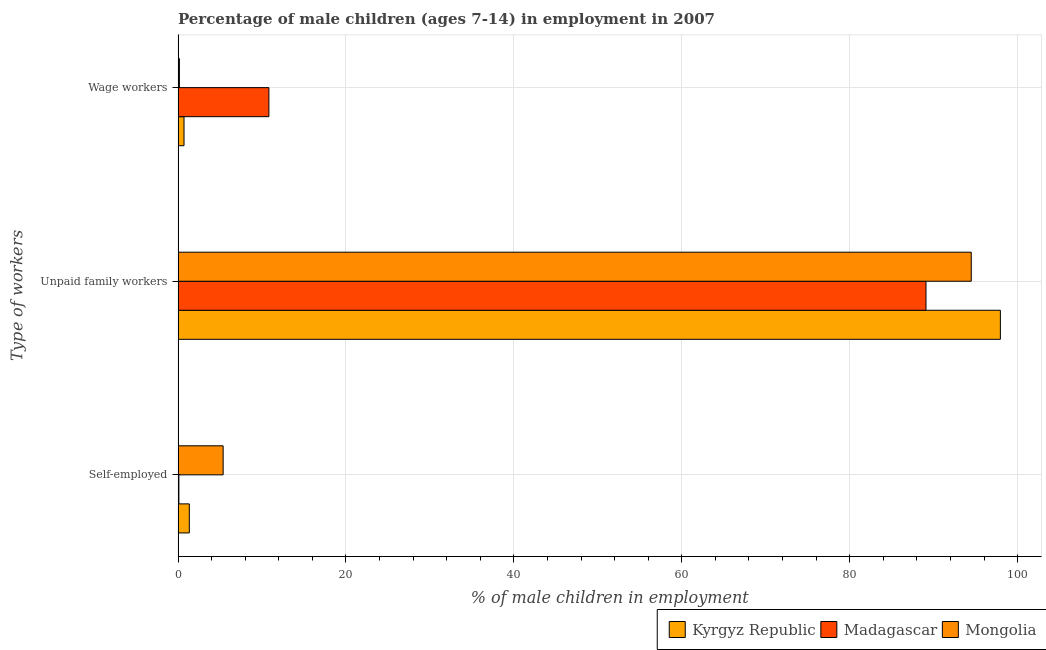How many different coloured bars are there?
Provide a short and direct response. 3. Are the number of bars on each tick of the Y-axis equal?
Offer a very short reply. Yes. What is the label of the 2nd group of bars from the top?
Your answer should be very brief. Unpaid family workers. What is the percentage of self employed children in Kyrgyz Republic?
Your answer should be very brief. 1.34. Across all countries, what is the maximum percentage of children employed as unpaid family workers?
Your answer should be very brief. 97.95. Across all countries, what is the minimum percentage of children employed as unpaid family workers?
Make the answer very short. 89.09. In which country was the percentage of children employed as wage workers maximum?
Offer a very short reply. Madagascar. In which country was the percentage of children employed as wage workers minimum?
Make the answer very short. Mongolia. What is the total percentage of children employed as wage workers in the graph?
Your answer should be compact. 11.69. What is the difference between the percentage of children employed as wage workers in Mongolia and that in Madagascar?
Make the answer very short. -10.66. What is the difference between the percentage of self employed children in Mongolia and the percentage of children employed as unpaid family workers in Madagascar?
Your answer should be compact. -83.72. What is the average percentage of self employed children per country?
Offer a terse response. 2.27. What is the difference between the percentage of self employed children and percentage of children employed as unpaid family workers in Kyrgyz Republic?
Your answer should be compact. -96.61. What is the ratio of the percentage of children employed as wage workers in Mongolia to that in Madagascar?
Provide a succinct answer. 0.01. Is the percentage of children employed as unpaid family workers in Kyrgyz Republic less than that in Madagascar?
Provide a short and direct response. No. What is the difference between the highest and the second highest percentage of children employed as wage workers?
Offer a very short reply. 10.11. What is the difference between the highest and the lowest percentage of children employed as unpaid family workers?
Ensure brevity in your answer.  8.86. In how many countries, is the percentage of children employed as wage workers greater than the average percentage of children employed as wage workers taken over all countries?
Ensure brevity in your answer.  1. Is the sum of the percentage of self employed children in Kyrgyz Republic and Mongolia greater than the maximum percentage of children employed as unpaid family workers across all countries?
Give a very brief answer. No. What does the 1st bar from the top in Unpaid family workers represents?
Give a very brief answer. Mongolia. What does the 2nd bar from the bottom in Unpaid family workers represents?
Make the answer very short. Madagascar. Does the graph contain grids?
Offer a very short reply. Yes. How many legend labels are there?
Keep it short and to the point. 3. What is the title of the graph?
Keep it short and to the point. Percentage of male children (ages 7-14) in employment in 2007. Does "Niger" appear as one of the legend labels in the graph?
Provide a short and direct response. No. What is the label or title of the X-axis?
Your answer should be compact. % of male children in employment. What is the label or title of the Y-axis?
Provide a short and direct response. Type of workers. What is the % of male children in employment in Kyrgyz Republic in Self-employed?
Your response must be concise. 1.34. What is the % of male children in employment in Madagascar in Self-employed?
Provide a short and direct response. 0.1. What is the % of male children in employment of Mongolia in Self-employed?
Keep it short and to the point. 5.37. What is the % of male children in employment of Kyrgyz Republic in Unpaid family workers?
Your answer should be compact. 97.95. What is the % of male children in employment in Madagascar in Unpaid family workers?
Offer a terse response. 89.09. What is the % of male children in employment in Mongolia in Unpaid family workers?
Provide a short and direct response. 94.48. What is the % of male children in employment of Kyrgyz Republic in Wage workers?
Offer a terse response. 0.71. What is the % of male children in employment of Madagascar in Wage workers?
Ensure brevity in your answer.  10.82. What is the % of male children in employment in Mongolia in Wage workers?
Ensure brevity in your answer.  0.16. Across all Type of workers, what is the maximum % of male children in employment in Kyrgyz Republic?
Your response must be concise. 97.95. Across all Type of workers, what is the maximum % of male children in employment of Madagascar?
Give a very brief answer. 89.09. Across all Type of workers, what is the maximum % of male children in employment in Mongolia?
Your answer should be very brief. 94.48. Across all Type of workers, what is the minimum % of male children in employment of Kyrgyz Republic?
Provide a short and direct response. 0.71. Across all Type of workers, what is the minimum % of male children in employment in Mongolia?
Keep it short and to the point. 0.16. What is the total % of male children in employment of Kyrgyz Republic in the graph?
Offer a very short reply. 100. What is the total % of male children in employment of Madagascar in the graph?
Your answer should be compact. 100.01. What is the total % of male children in employment in Mongolia in the graph?
Offer a very short reply. 100.01. What is the difference between the % of male children in employment of Kyrgyz Republic in Self-employed and that in Unpaid family workers?
Offer a terse response. -96.61. What is the difference between the % of male children in employment of Madagascar in Self-employed and that in Unpaid family workers?
Make the answer very short. -88.99. What is the difference between the % of male children in employment in Mongolia in Self-employed and that in Unpaid family workers?
Your answer should be compact. -89.11. What is the difference between the % of male children in employment of Kyrgyz Republic in Self-employed and that in Wage workers?
Provide a succinct answer. 0.63. What is the difference between the % of male children in employment of Madagascar in Self-employed and that in Wage workers?
Your response must be concise. -10.72. What is the difference between the % of male children in employment in Mongolia in Self-employed and that in Wage workers?
Your answer should be compact. 5.21. What is the difference between the % of male children in employment in Kyrgyz Republic in Unpaid family workers and that in Wage workers?
Your answer should be compact. 97.24. What is the difference between the % of male children in employment in Madagascar in Unpaid family workers and that in Wage workers?
Your answer should be compact. 78.27. What is the difference between the % of male children in employment in Mongolia in Unpaid family workers and that in Wage workers?
Your answer should be very brief. 94.32. What is the difference between the % of male children in employment of Kyrgyz Republic in Self-employed and the % of male children in employment of Madagascar in Unpaid family workers?
Give a very brief answer. -87.75. What is the difference between the % of male children in employment in Kyrgyz Republic in Self-employed and the % of male children in employment in Mongolia in Unpaid family workers?
Keep it short and to the point. -93.14. What is the difference between the % of male children in employment of Madagascar in Self-employed and the % of male children in employment of Mongolia in Unpaid family workers?
Provide a short and direct response. -94.38. What is the difference between the % of male children in employment of Kyrgyz Republic in Self-employed and the % of male children in employment of Madagascar in Wage workers?
Make the answer very short. -9.48. What is the difference between the % of male children in employment in Kyrgyz Republic in Self-employed and the % of male children in employment in Mongolia in Wage workers?
Provide a succinct answer. 1.18. What is the difference between the % of male children in employment of Madagascar in Self-employed and the % of male children in employment of Mongolia in Wage workers?
Your answer should be compact. -0.06. What is the difference between the % of male children in employment in Kyrgyz Republic in Unpaid family workers and the % of male children in employment in Madagascar in Wage workers?
Your answer should be very brief. 87.13. What is the difference between the % of male children in employment of Kyrgyz Republic in Unpaid family workers and the % of male children in employment of Mongolia in Wage workers?
Make the answer very short. 97.79. What is the difference between the % of male children in employment of Madagascar in Unpaid family workers and the % of male children in employment of Mongolia in Wage workers?
Your answer should be compact. 88.93. What is the average % of male children in employment of Kyrgyz Republic per Type of workers?
Ensure brevity in your answer.  33.33. What is the average % of male children in employment in Madagascar per Type of workers?
Offer a very short reply. 33.34. What is the average % of male children in employment of Mongolia per Type of workers?
Give a very brief answer. 33.34. What is the difference between the % of male children in employment in Kyrgyz Republic and % of male children in employment in Madagascar in Self-employed?
Provide a short and direct response. 1.24. What is the difference between the % of male children in employment of Kyrgyz Republic and % of male children in employment of Mongolia in Self-employed?
Offer a terse response. -4.03. What is the difference between the % of male children in employment of Madagascar and % of male children in employment of Mongolia in Self-employed?
Your response must be concise. -5.27. What is the difference between the % of male children in employment of Kyrgyz Republic and % of male children in employment of Madagascar in Unpaid family workers?
Keep it short and to the point. 8.86. What is the difference between the % of male children in employment of Kyrgyz Republic and % of male children in employment of Mongolia in Unpaid family workers?
Provide a succinct answer. 3.47. What is the difference between the % of male children in employment of Madagascar and % of male children in employment of Mongolia in Unpaid family workers?
Offer a terse response. -5.39. What is the difference between the % of male children in employment in Kyrgyz Republic and % of male children in employment in Madagascar in Wage workers?
Your response must be concise. -10.11. What is the difference between the % of male children in employment of Kyrgyz Republic and % of male children in employment of Mongolia in Wage workers?
Give a very brief answer. 0.55. What is the difference between the % of male children in employment of Madagascar and % of male children in employment of Mongolia in Wage workers?
Your answer should be very brief. 10.66. What is the ratio of the % of male children in employment in Kyrgyz Republic in Self-employed to that in Unpaid family workers?
Ensure brevity in your answer.  0.01. What is the ratio of the % of male children in employment in Madagascar in Self-employed to that in Unpaid family workers?
Keep it short and to the point. 0. What is the ratio of the % of male children in employment in Mongolia in Self-employed to that in Unpaid family workers?
Provide a short and direct response. 0.06. What is the ratio of the % of male children in employment in Kyrgyz Republic in Self-employed to that in Wage workers?
Offer a very short reply. 1.89. What is the ratio of the % of male children in employment of Madagascar in Self-employed to that in Wage workers?
Keep it short and to the point. 0.01. What is the ratio of the % of male children in employment of Mongolia in Self-employed to that in Wage workers?
Provide a succinct answer. 33.56. What is the ratio of the % of male children in employment of Kyrgyz Republic in Unpaid family workers to that in Wage workers?
Offer a very short reply. 137.96. What is the ratio of the % of male children in employment in Madagascar in Unpaid family workers to that in Wage workers?
Give a very brief answer. 8.23. What is the ratio of the % of male children in employment of Mongolia in Unpaid family workers to that in Wage workers?
Offer a terse response. 590.5. What is the difference between the highest and the second highest % of male children in employment in Kyrgyz Republic?
Offer a very short reply. 96.61. What is the difference between the highest and the second highest % of male children in employment of Madagascar?
Offer a very short reply. 78.27. What is the difference between the highest and the second highest % of male children in employment of Mongolia?
Your answer should be compact. 89.11. What is the difference between the highest and the lowest % of male children in employment in Kyrgyz Republic?
Your answer should be very brief. 97.24. What is the difference between the highest and the lowest % of male children in employment of Madagascar?
Provide a short and direct response. 88.99. What is the difference between the highest and the lowest % of male children in employment in Mongolia?
Your response must be concise. 94.32. 